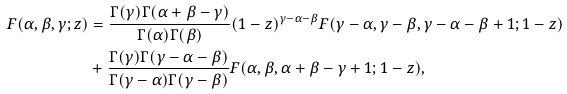Convert formula to latex. <formula><loc_0><loc_0><loc_500><loc_500>F ( \alpha , \beta , \gamma ; z ) & = \frac { \Gamma ( \gamma ) \Gamma ( \alpha + \beta - \gamma ) } { \Gamma ( \alpha ) \Gamma ( \beta ) } ( 1 - z ) ^ { \gamma - \alpha - \beta } F ( \gamma - \alpha , \gamma - \beta , \gamma - \alpha - \beta + 1 ; 1 - z ) \\ & + \frac { \Gamma ( \gamma ) \Gamma ( \gamma - \alpha - \beta ) } { \Gamma ( \gamma - \alpha ) \Gamma ( \gamma - \beta ) } F ( \alpha , \beta , \alpha + \beta - \gamma + 1 ; 1 - z ) ,</formula> 